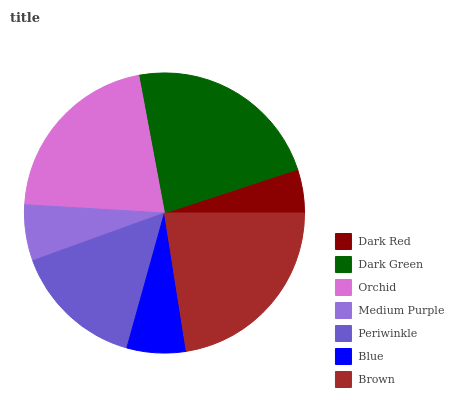Is Dark Red the minimum?
Answer yes or no. Yes. Is Dark Green the maximum?
Answer yes or no. Yes. Is Orchid the minimum?
Answer yes or no. No. Is Orchid the maximum?
Answer yes or no. No. Is Dark Green greater than Orchid?
Answer yes or no. Yes. Is Orchid less than Dark Green?
Answer yes or no. Yes. Is Orchid greater than Dark Green?
Answer yes or no. No. Is Dark Green less than Orchid?
Answer yes or no. No. Is Periwinkle the high median?
Answer yes or no. Yes. Is Periwinkle the low median?
Answer yes or no. Yes. Is Dark Green the high median?
Answer yes or no. No. Is Blue the low median?
Answer yes or no. No. 